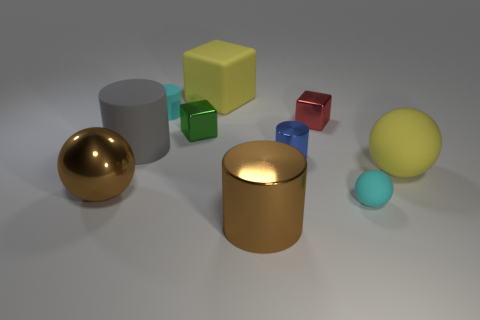There is a matte thing that is the same color as the large rubber cube; what size is it?
Provide a short and direct response. Large. How many matte things are purple cylinders or cubes?
Your answer should be very brief. 1. There is a matte object left of the cyan object that is behind the tiny shiny cylinder; is there a big matte cylinder behind it?
Provide a short and direct response. No. How many large matte objects are behind the gray cylinder?
Ensure brevity in your answer.  1. There is a large ball that is the same color as the matte cube; what material is it?
Keep it short and to the point. Rubber. How many big things are either brown rubber things or gray cylinders?
Your answer should be compact. 1. There is a large thing on the right side of the small red shiny object; what is its shape?
Your response must be concise. Sphere. Are there any spheres that have the same color as the big shiny cylinder?
Your answer should be very brief. Yes. Do the ball that is on the left side of the small matte sphere and the yellow object that is in front of the blue metal object have the same size?
Offer a very short reply. Yes. Is the number of cyan cylinders that are to the left of the big gray matte cylinder greater than the number of matte cubes that are in front of the tiny sphere?
Keep it short and to the point. No. 